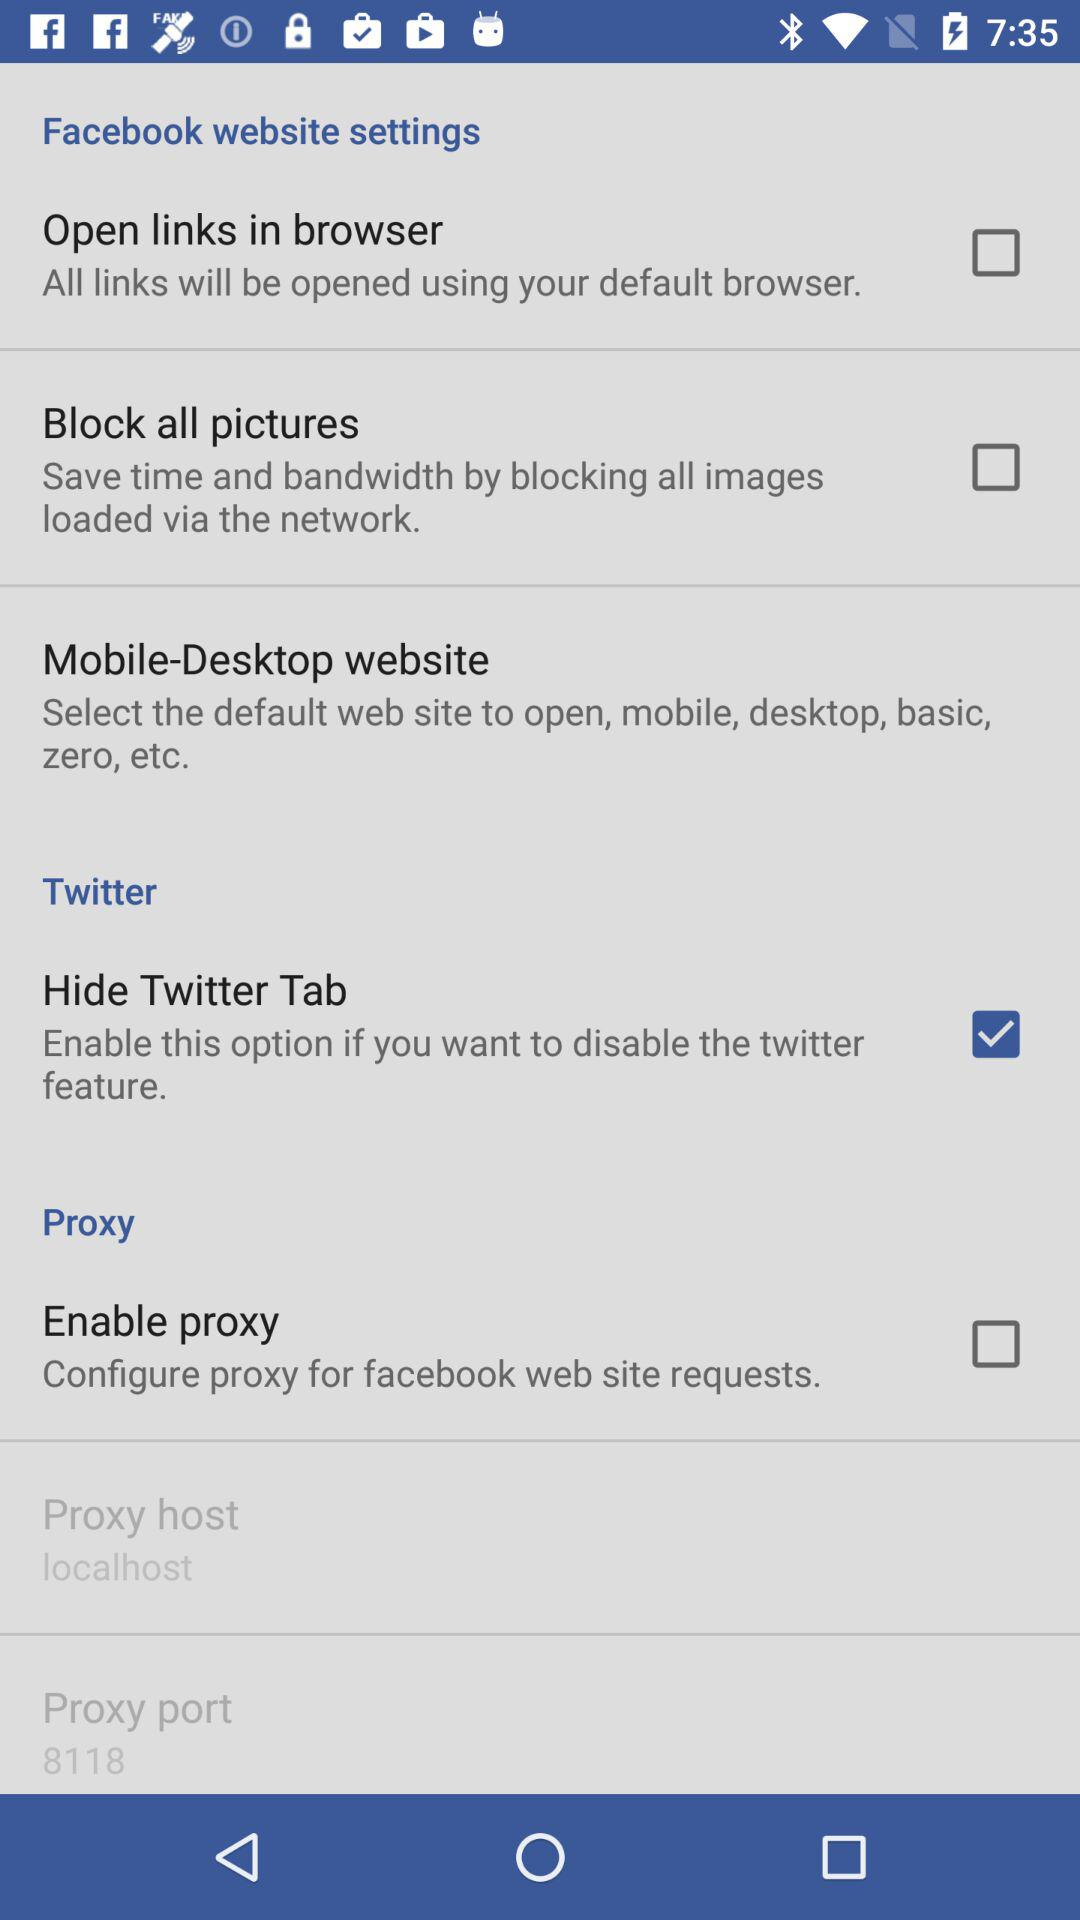What is the number of proxy ports? The number of proxy ports is 8118. 